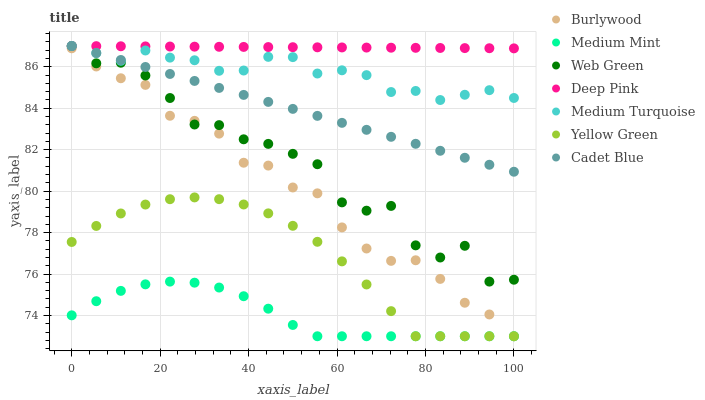Does Medium Mint have the minimum area under the curve?
Answer yes or no. Yes. Does Deep Pink have the maximum area under the curve?
Answer yes or no. Yes. Does Yellow Green have the minimum area under the curve?
Answer yes or no. No. Does Yellow Green have the maximum area under the curve?
Answer yes or no. No. Is Deep Pink the smoothest?
Answer yes or no. Yes. Is Web Green the roughest?
Answer yes or no. Yes. Is Yellow Green the smoothest?
Answer yes or no. No. Is Yellow Green the roughest?
Answer yes or no. No. Does Medium Mint have the lowest value?
Answer yes or no. Yes. Does Deep Pink have the lowest value?
Answer yes or no. No. Does Medium Turquoise have the highest value?
Answer yes or no. Yes. Does Yellow Green have the highest value?
Answer yes or no. No. Is Burlywood less than Deep Pink?
Answer yes or no. Yes. Is Cadet Blue greater than Burlywood?
Answer yes or no. Yes. Does Medium Mint intersect Burlywood?
Answer yes or no. Yes. Is Medium Mint less than Burlywood?
Answer yes or no. No. Is Medium Mint greater than Burlywood?
Answer yes or no. No. Does Burlywood intersect Deep Pink?
Answer yes or no. No. 